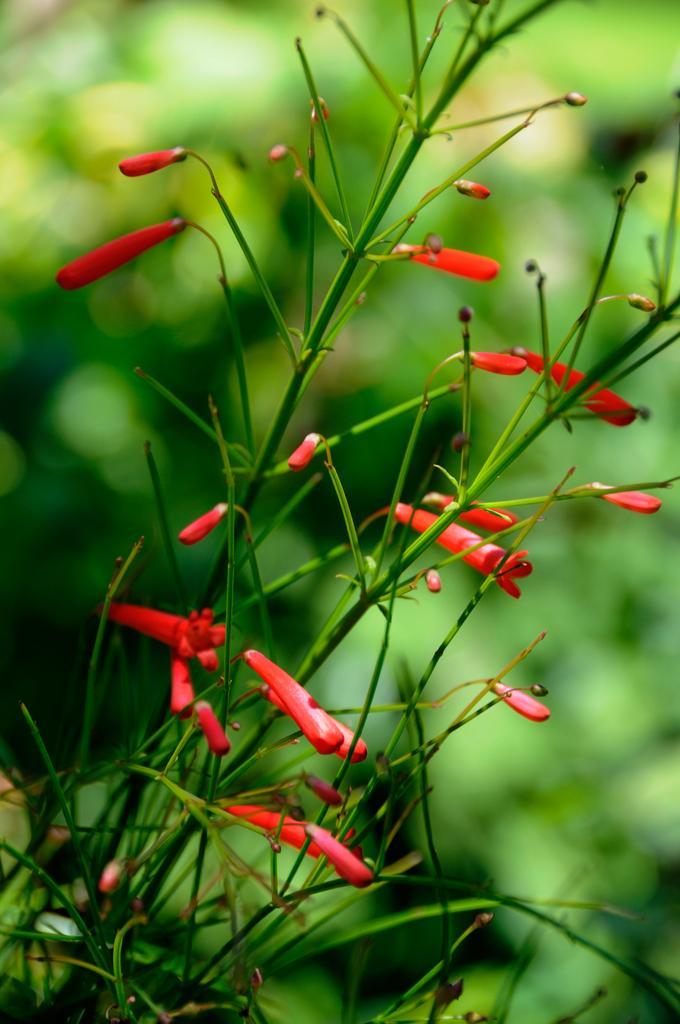Can you describe this image briefly? As we can see in the image in the front there are plants and red color flowers. The background is blurred. 